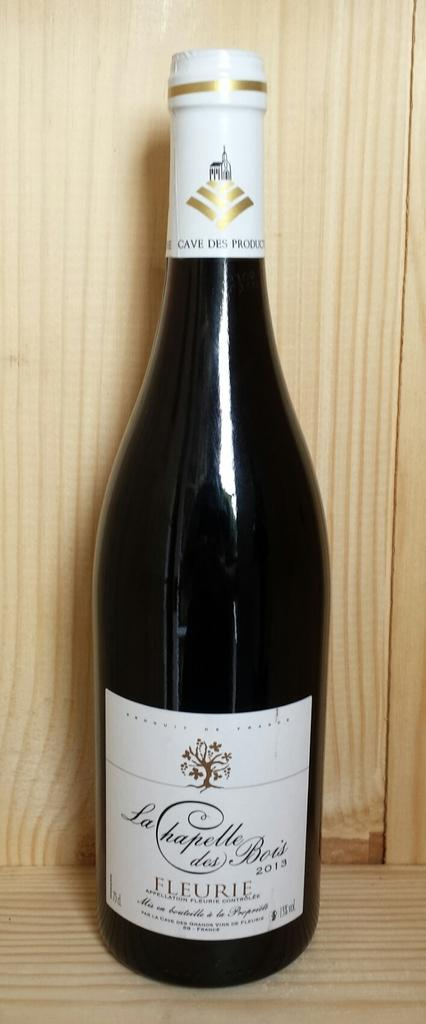<image>
Give a short and clear explanation of the subsequent image. Bottle of Fleurie wine that is a caves des product. 